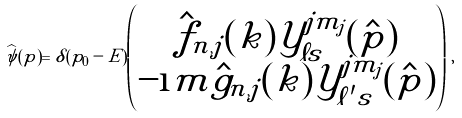Convert formula to latex. <formula><loc_0><loc_0><loc_500><loc_500>\widehat { \psi } ( p ) = \delta ( p _ { 0 } - E ) \left ( \begin{matrix} \hat { f } _ { n , j } ( k ) \mathcal { Y } _ { \ell s } ^ { j m _ { j } } ( \hat { p } ) \\ - \i m \hat { g } _ { n , j } ( k ) \mathcal { Y } _ { \ell ^ { \prime } s } ^ { j m _ { j } } ( \hat { p } ) \end{matrix} \right ) \, ,</formula> 